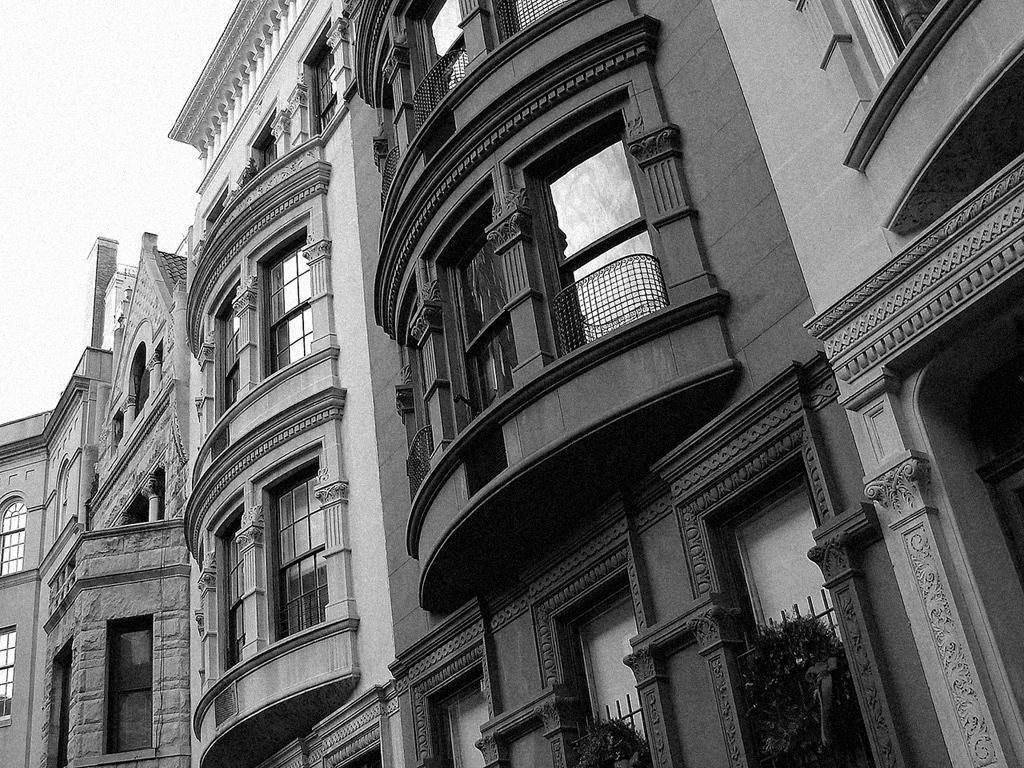What type of structures are present in the image? There are buildings in the image. What features can be observed on the buildings? The buildings have windows and grills. What else can be seen in the image besides the buildings? There are plants visible in the image. What type of voice can be heard coming from the buildings in the image? There is no voice present in the image; it only contains visual elements. 